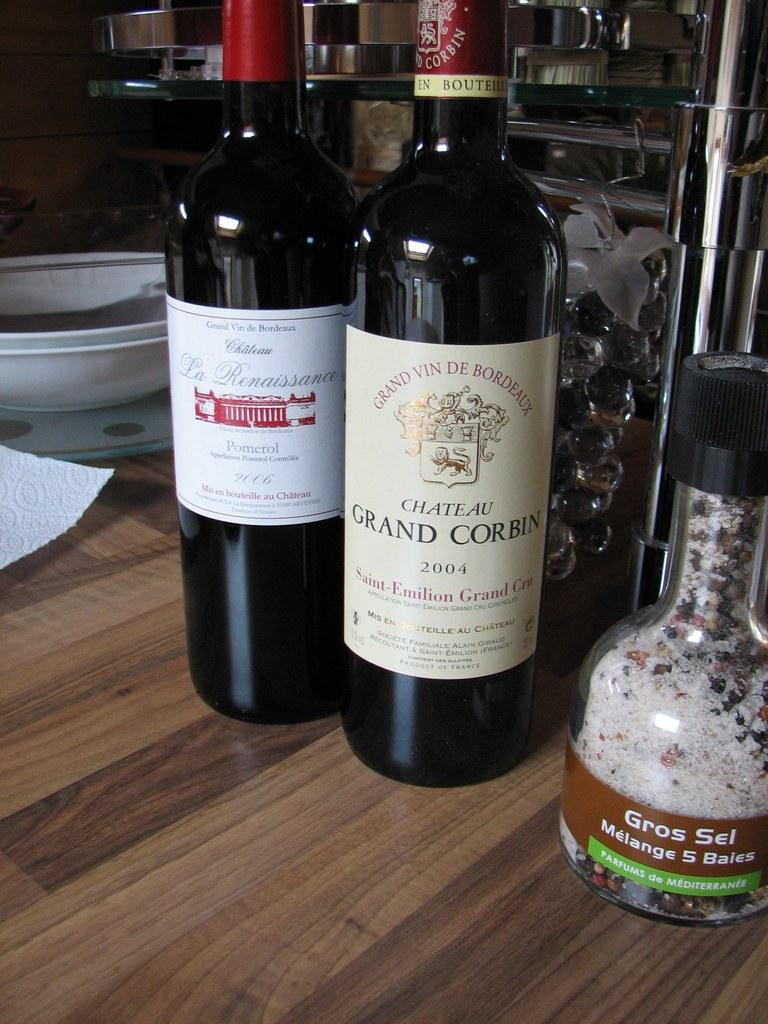<image>
Describe the image concisely. A bottle of Chateau Grand Corbin wine on the table with other bottles. 